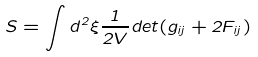Convert formula to latex. <formula><loc_0><loc_0><loc_500><loc_500>S = \int d ^ { 2 } \xi \frac { 1 } { 2 V } d e t ( g _ { i j } + 2 F _ { i j } )</formula> 